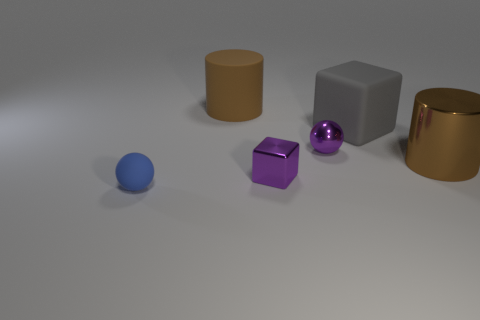Add 4 cylinders. How many objects exist? 10 Subtract all balls. How many objects are left? 4 Add 6 tiny purple cylinders. How many tiny purple cylinders exist? 6 Subtract 0 brown balls. How many objects are left? 6 Subtract all small gray rubber cylinders. Subtract all gray blocks. How many objects are left? 5 Add 3 big gray things. How many big gray things are left? 4 